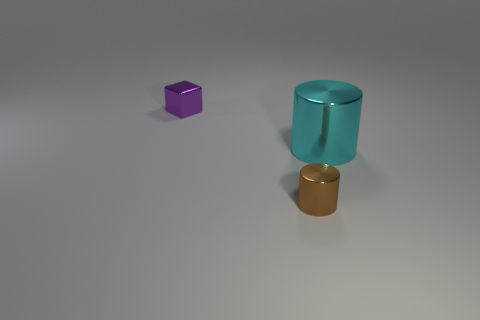Add 2 metal cubes. How many objects exist? 5 Subtract all cylinders. How many objects are left? 1 Add 1 tiny purple things. How many tiny purple things exist? 2 Subtract 0 blue spheres. How many objects are left? 3 Subtract all large shiny cylinders. Subtract all cyan objects. How many objects are left? 1 Add 3 tiny cylinders. How many tiny cylinders are left? 4 